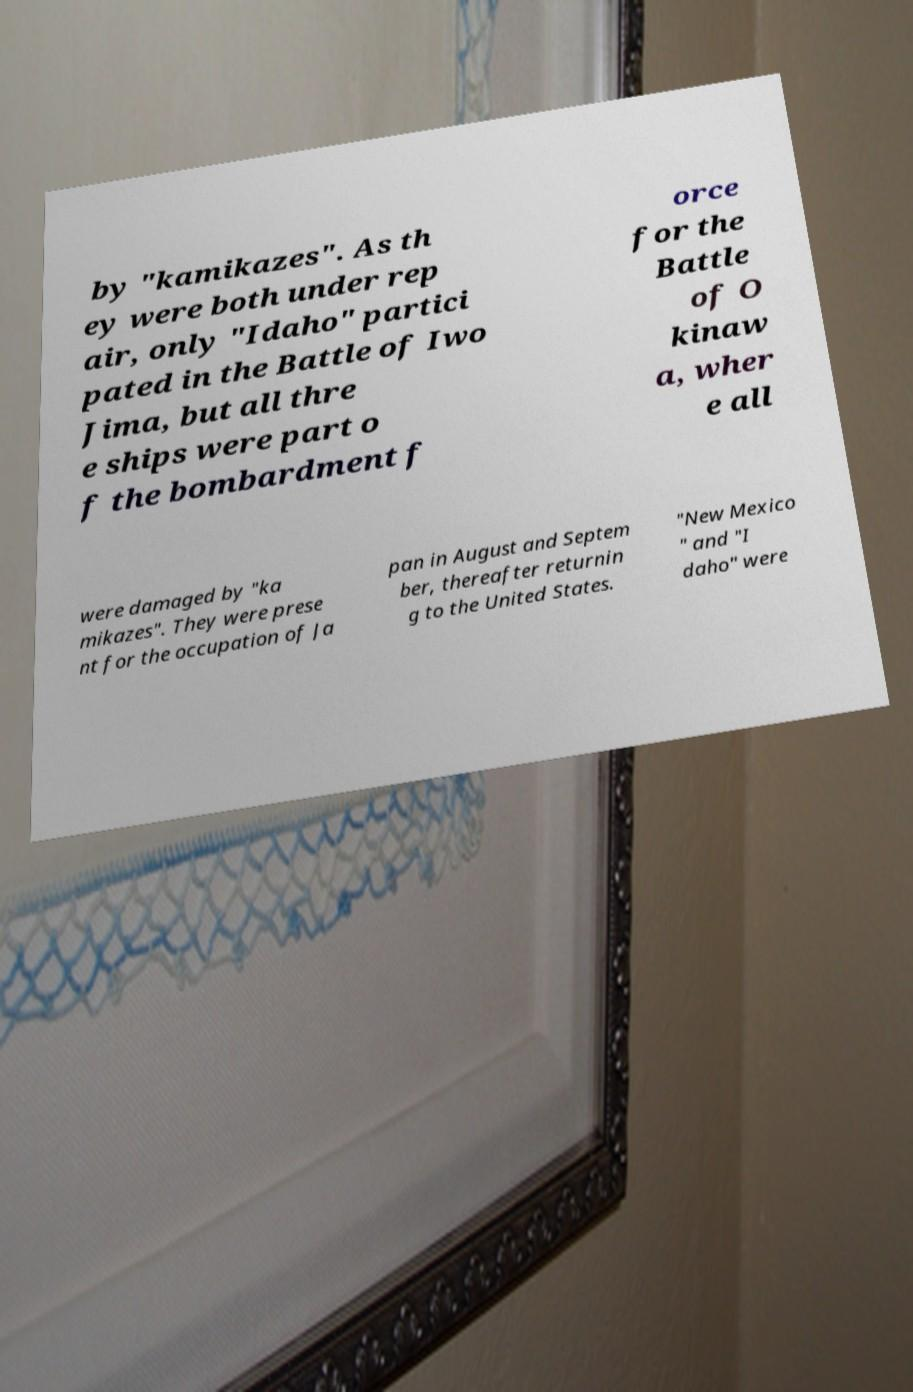There's text embedded in this image that I need extracted. Can you transcribe it verbatim? by "kamikazes". As th ey were both under rep air, only "Idaho" partici pated in the Battle of Iwo Jima, but all thre e ships were part o f the bombardment f orce for the Battle of O kinaw a, wher e all were damaged by "ka mikazes". They were prese nt for the occupation of Ja pan in August and Septem ber, thereafter returnin g to the United States. "New Mexico " and "I daho" were 